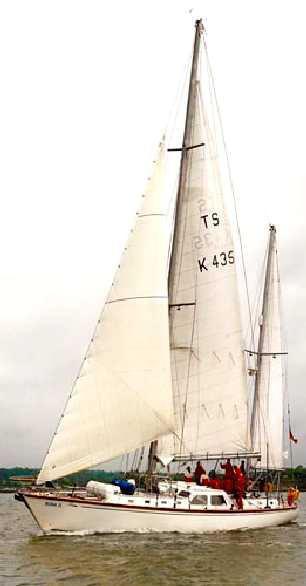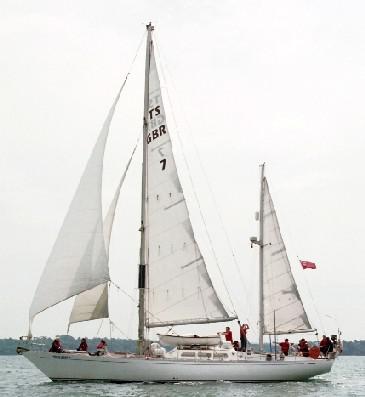The first image is the image on the left, the second image is the image on the right. Evaluate the accuracy of this statement regarding the images: "there are puffy clouds in one of the images". Is it true? Answer yes or no. No. 